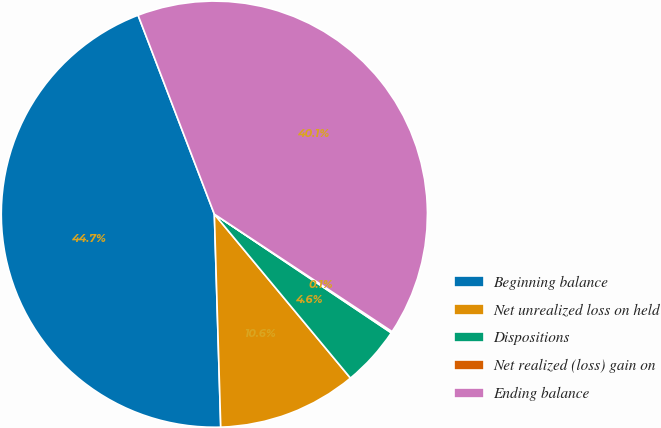Convert chart. <chart><loc_0><loc_0><loc_500><loc_500><pie_chart><fcel>Beginning balance<fcel>Net unrealized loss on held<fcel>Dispositions<fcel>Net realized (loss) gain on<fcel>Ending balance<nl><fcel>44.65%<fcel>10.55%<fcel>4.57%<fcel>0.11%<fcel>40.12%<nl></chart> 